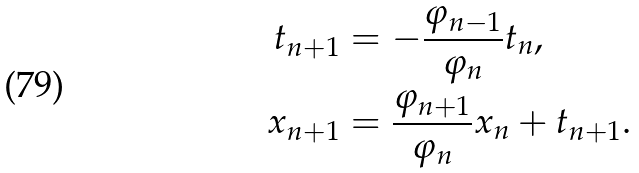Convert formula to latex. <formula><loc_0><loc_0><loc_500><loc_500>t _ { n + 1 } & = - \frac { \varphi _ { n - 1 } } { \varphi _ { n } } t _ { n } , \\ x _ { n + 1 } & = \frac { \varphi _ { n + 1 } } { \varphi _ { n } } x _ { n } + t _ { n + 1 } .</formula> 